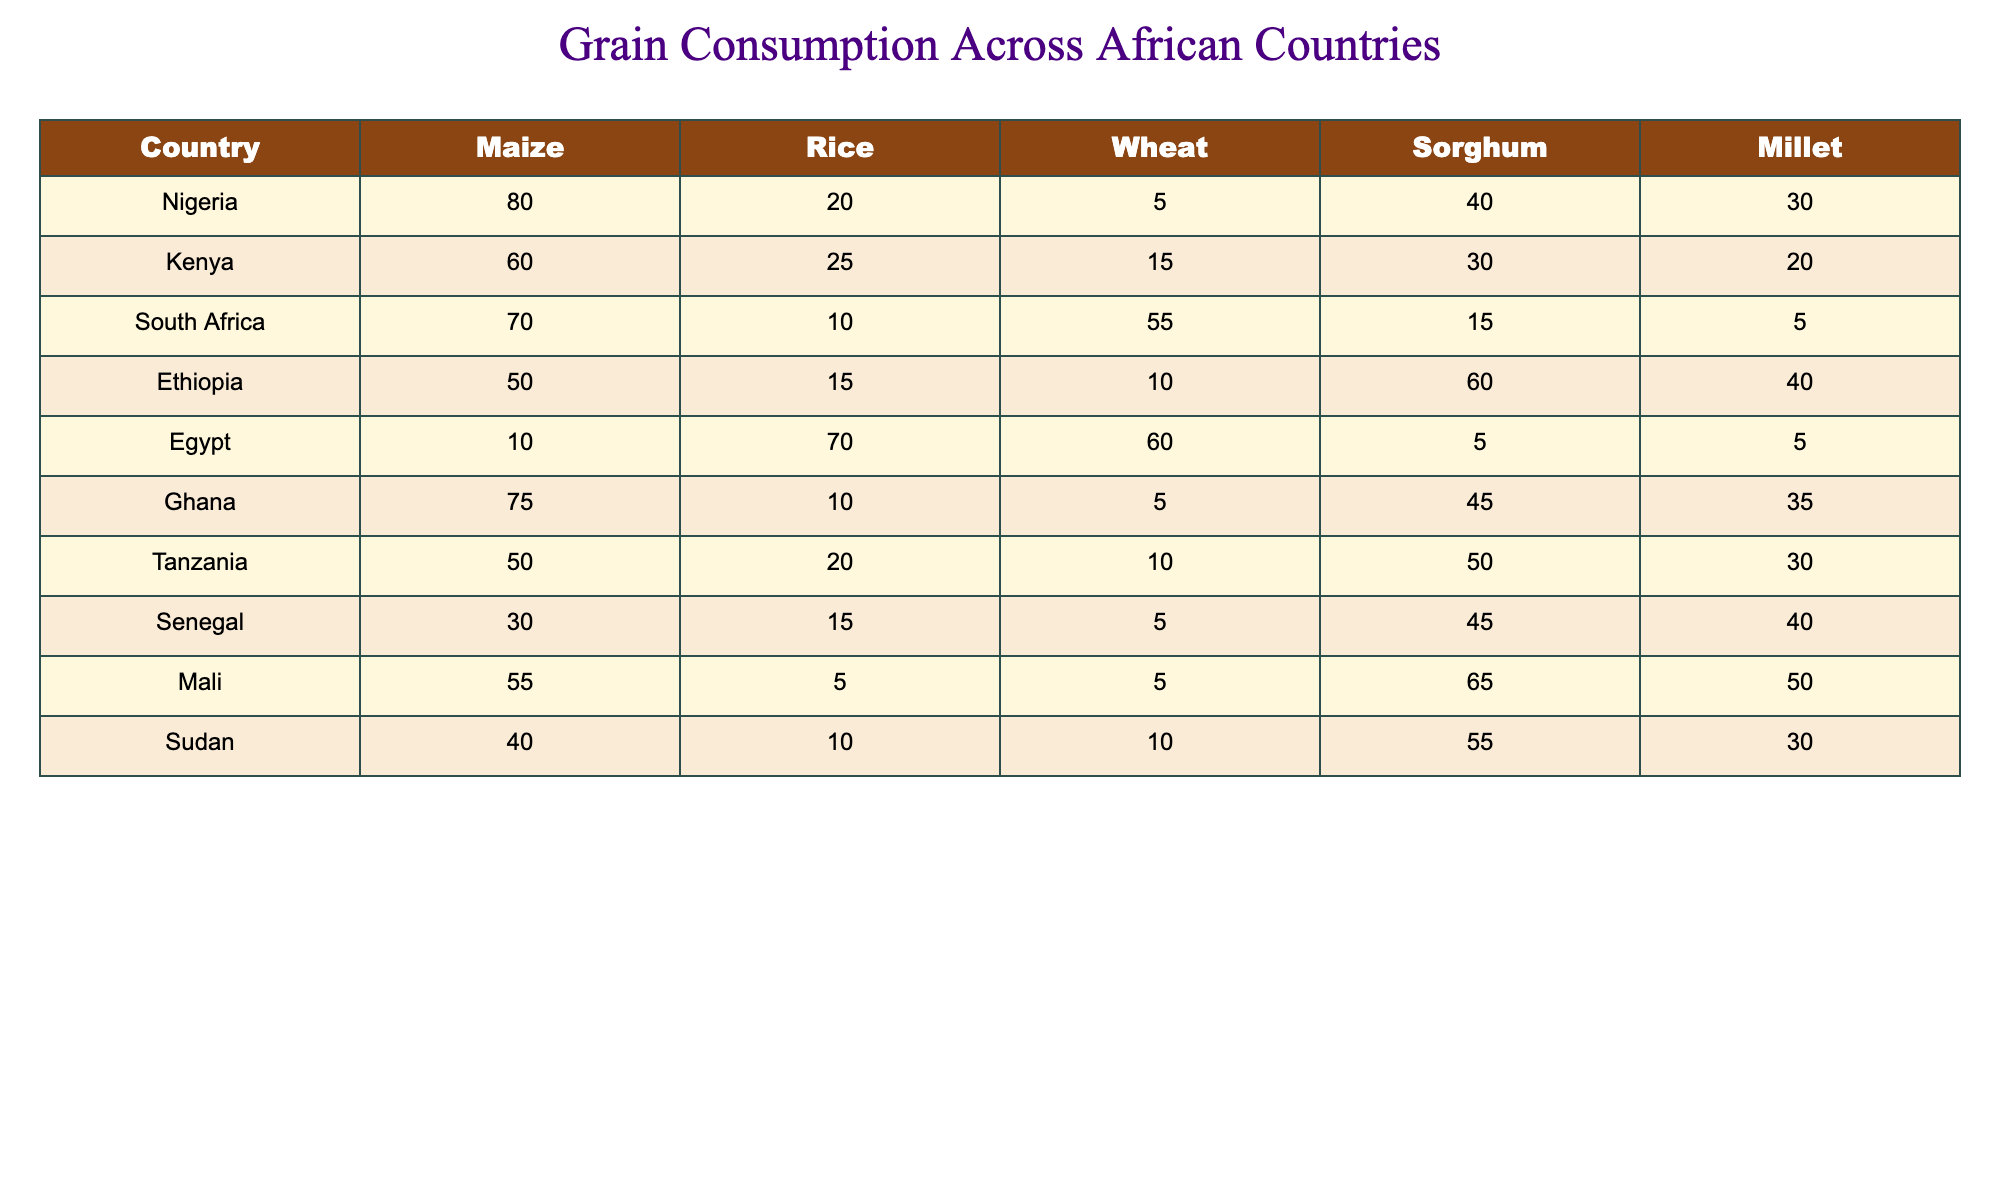What is the most consumed grain in Nigeria? From the data, Nigeria has the highest consumption of maize, which is listed as 80. Therefore, maize is the most consumed grain in Nigeria.
Answer: Maize Which country has the lowest rice consumption? Examining the rice consumption values, Mali shows the lowest consumption at 5. Thus, Mali is the country with the lowest rice consumption.
Answer: Mali How many more tons of sorghum does Mali consume compared to Egypt? Mali consumes 65 tons of sorghum while Egypt consumes 5 tons. The difference is 65 - 5 = 60 tons, meaning Mali consumes 60 tons more sorghum than Egypt.
Answer: 60 tons Which two countries have the highest and lowest wheat consumption, respectively? South Africa has the highest wheat consumption with 55 tons, while Mali has the lowest wheat consumption at 5 tons, based on the respective values in the table.
Answer: South Africa (highest), Mali (lowest) Is the average consumption of millet in Ethiopia and Senegal greater than 30? Ethiopia consumes 40 tons of millet and Senegal consumes 40 tons as well. The average is (40 + 40) / 2 = 40, which is greater than 30. Therefore, the statement is true.
Answer: Yes Which grains do Kenya and Ghana both consume more than 20 tons? Looking at the grains consumed by Kenya (Maize 60, Rice 25, Sorghum 30) and Ghana (Maize 75, Sorghum 45, Millet 35), both countries consume maize and sorghum in quantities greater than 20 tons.
Answer: Maize and Sorghum What is the total consumption of all grains in Sudan? Summing the values for Sudan yields 40 (Maize) + 10 (Rice) + 10 (Wheat) + 55 (Sorghum) + 30 (Millet) = 145 tons. Therefore, the total consumption of all grains in Sudan is 145 tons.
Answer: 145 tons Which country has a higher total grain consumption: Tanzania or Ethiopia? The total for Tanzania is 50 (Maize) + 20 (Rice) + 10 (Wheat) + 50 (Sorghum) + 30 (Millet) = 160 tons. For Ethiopia, it is 50 (Maize) + 15 (Rice) + 10 (Wheat) + 60 (Sorghum) + 40 (Millet) = 175 tons. Since 175 is greater than 160, Ethiopia has higher total consumption.
Answer: Ethiopia Do more countries consume maize than any other grain in this table? A review of the table shows that maize is the highest for Nigeria, Kenya, South Africa, Ghana, and Tanzania, totaling five countries. Comparing with other grains, only rice is consumed by five countries as well. Thus, more counties do not exclusively consume maize more than other grains.
Answer: No 